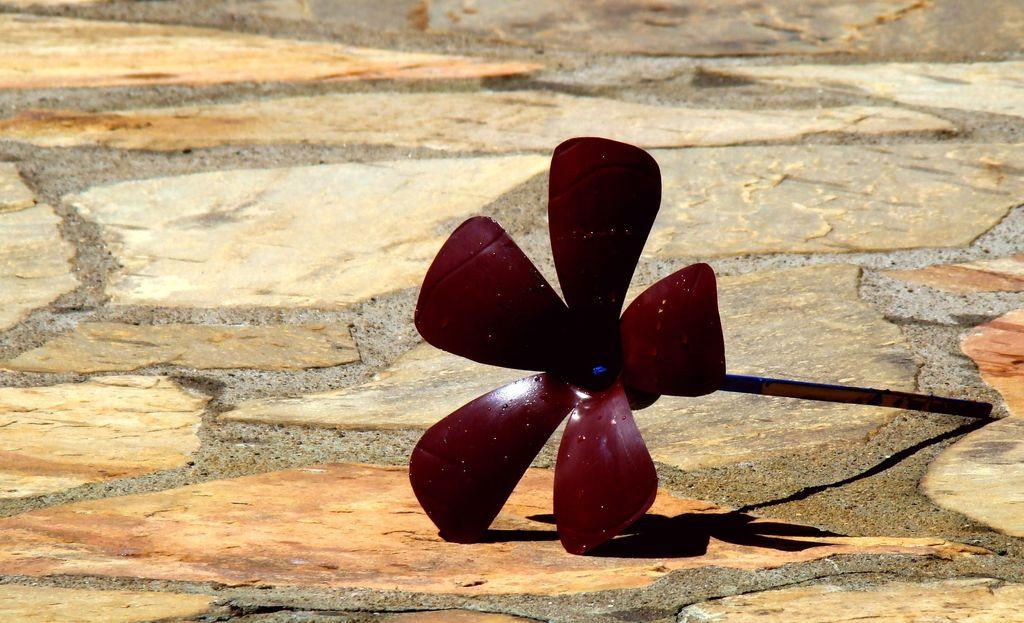What is the main object in the image? There is a maroon color flower shaped object in the image. How is the object positioned in the image? The object is placed on the land. What is connected to the object? There is a stick connected to the object. What can be seen in the background of the image? There is an open land in the background of the image. What type of credit does the minister offer to the object in the image? There is no mention of a minister or credit in the image; it features a maroon color flower shaped object with a stick connected to it, placed on the land, and set against an open land background. 